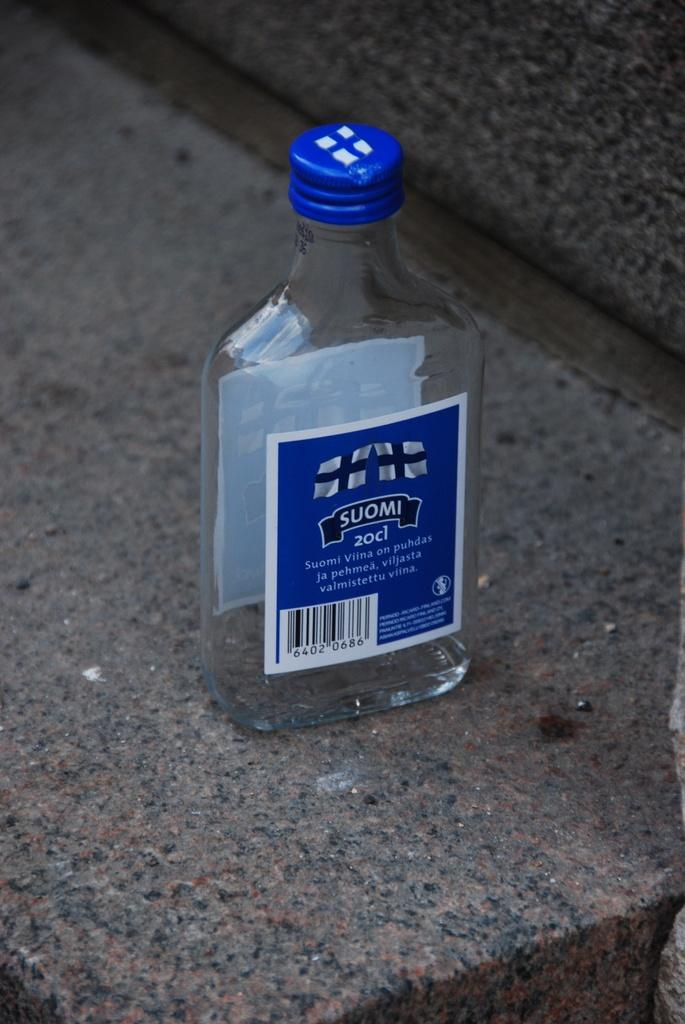What object is present in the image that appears to be empty? There is an empty bottle in the image. What type of hair is visible on the bottle in the image? There is no hair visible on the bottle in the image, as it is an empty bottle. What type of juice might have been in the bottle before it became empty? The image does not provide any information about the type of juice that might have been in the bottle before it became empty. 